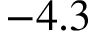Convert formula to latex. <formula><loc_0><loc_0><loc_500><loc_500>- 4 . 3</formula> 